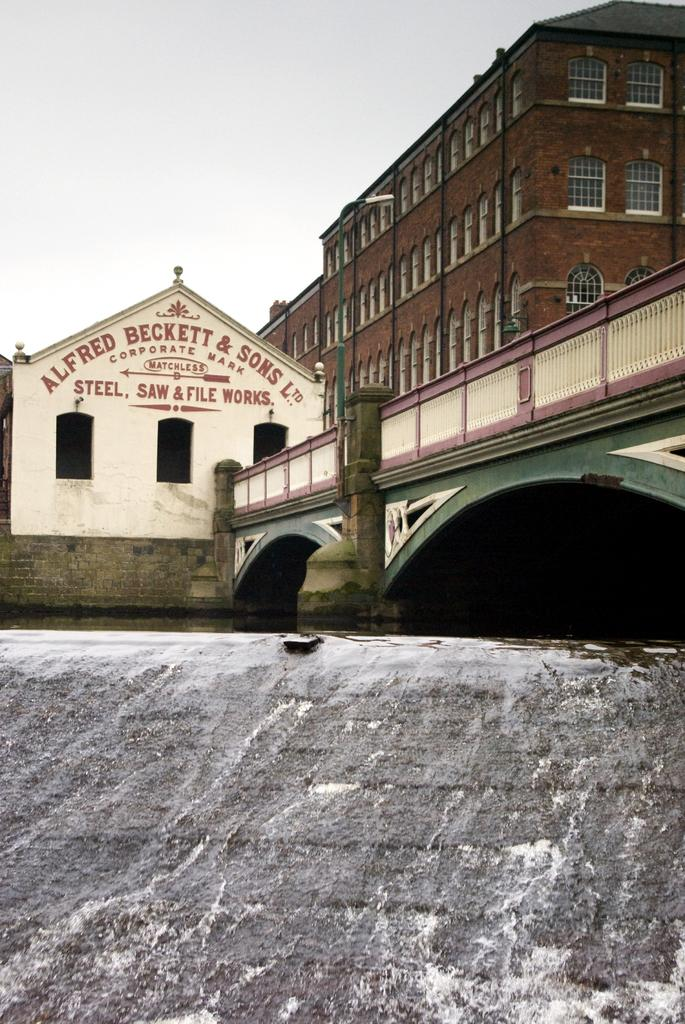What is the main structure visible in the image? There is a wall in the image. What can be seen behind the wall? There are buildings behind the wall. What type of architectural feature is present in the image? There is a bridge in the image. Can you read any text in the image? Yes, there is text on a building in the image. What is visible at the top of the image? The sky is visible at the top of the image. How many mice are hiding behind the curtain in the image? There is no curtain or mice present in the image. 